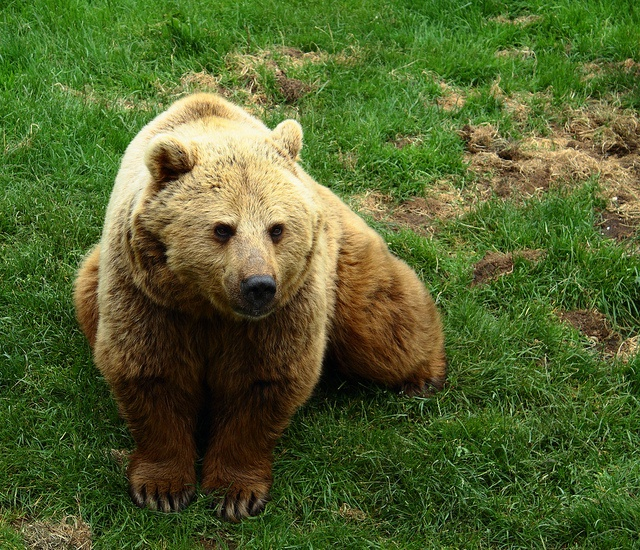Describe the objects in this image and their specific colors. I can see a bear in darkgreen, black, khaki, olive, and maroon tones in this image. 